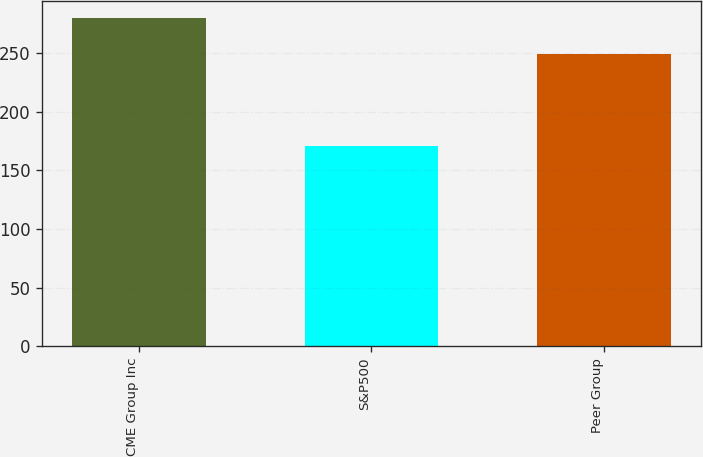<chart> <loc_0><loc_0><loc_500><loc_500><bar_chart><fcel>CME Group Inc<fcel>S&P500<fcel>Peer Group<nl><fcel>279.85<fcel>170.84<fcel>249.31<nl></chart> 